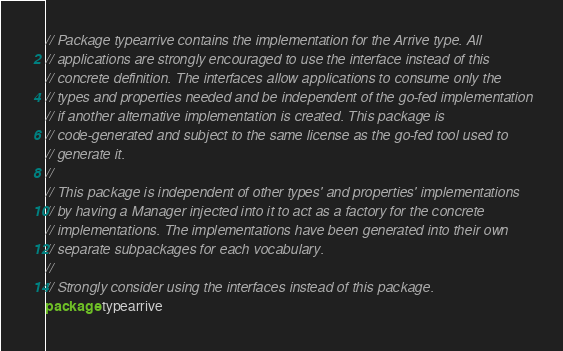<code> <loc_0><loc_0><loc_500><loc_500><_Go_>// Package typearrive contains the implementation for the Arrive type. All
// applications are strongly encouraged to use the interface instead of this
// concrete definition. The interfaces allow applications to consume only the
// types and properties needed and be independent of the go-fed implementation
// if another alternative implementation is created. This package is
// code-generated and subject to the same license as the go-fed tool used to
// generate it.
//
// This package is independent of other types' and properties' implementations
// by having a Manager injected into it to act as a factory for the concrete
// implementations. The implementations have been generated into their own
// separate subpackages for each vocabulary.
//
// Strongly consider using the interfaces instead of this package.
package typearrive
</code> 